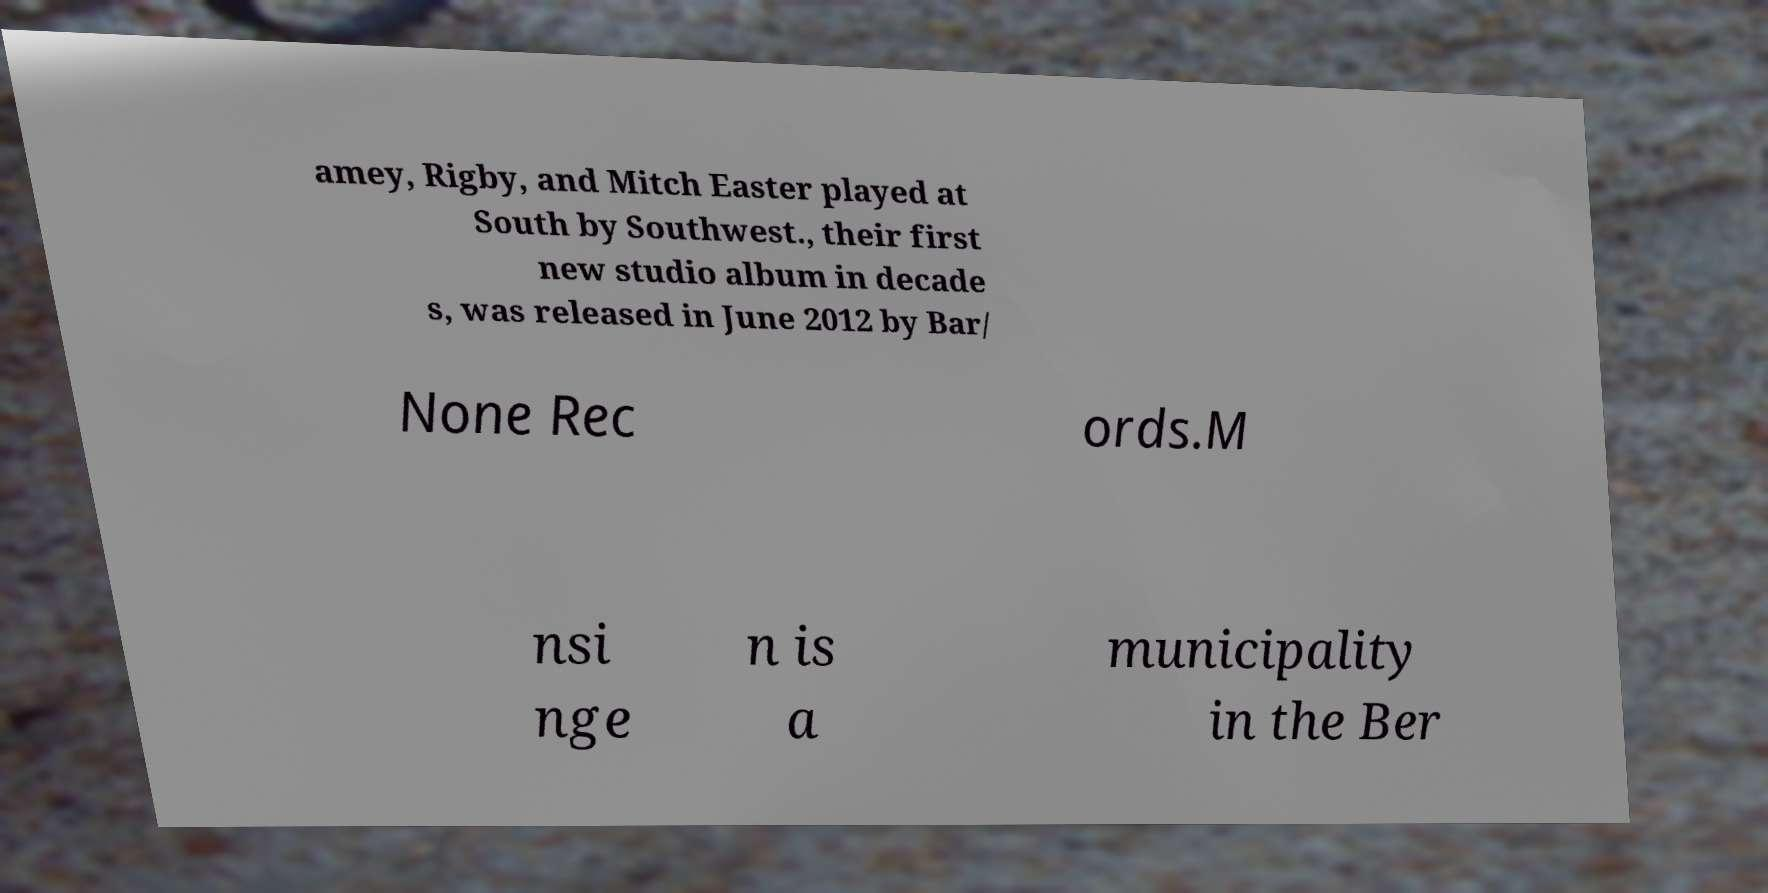I need the written content from this picture converted into text. Can you do that? amey, Rigby, and Mitch Easter played at South by Southwest., their first new studio album in decade s, was released in June 2012 by Bar/ None Rec ords.M nsi nge n is a municipality in the Ber 